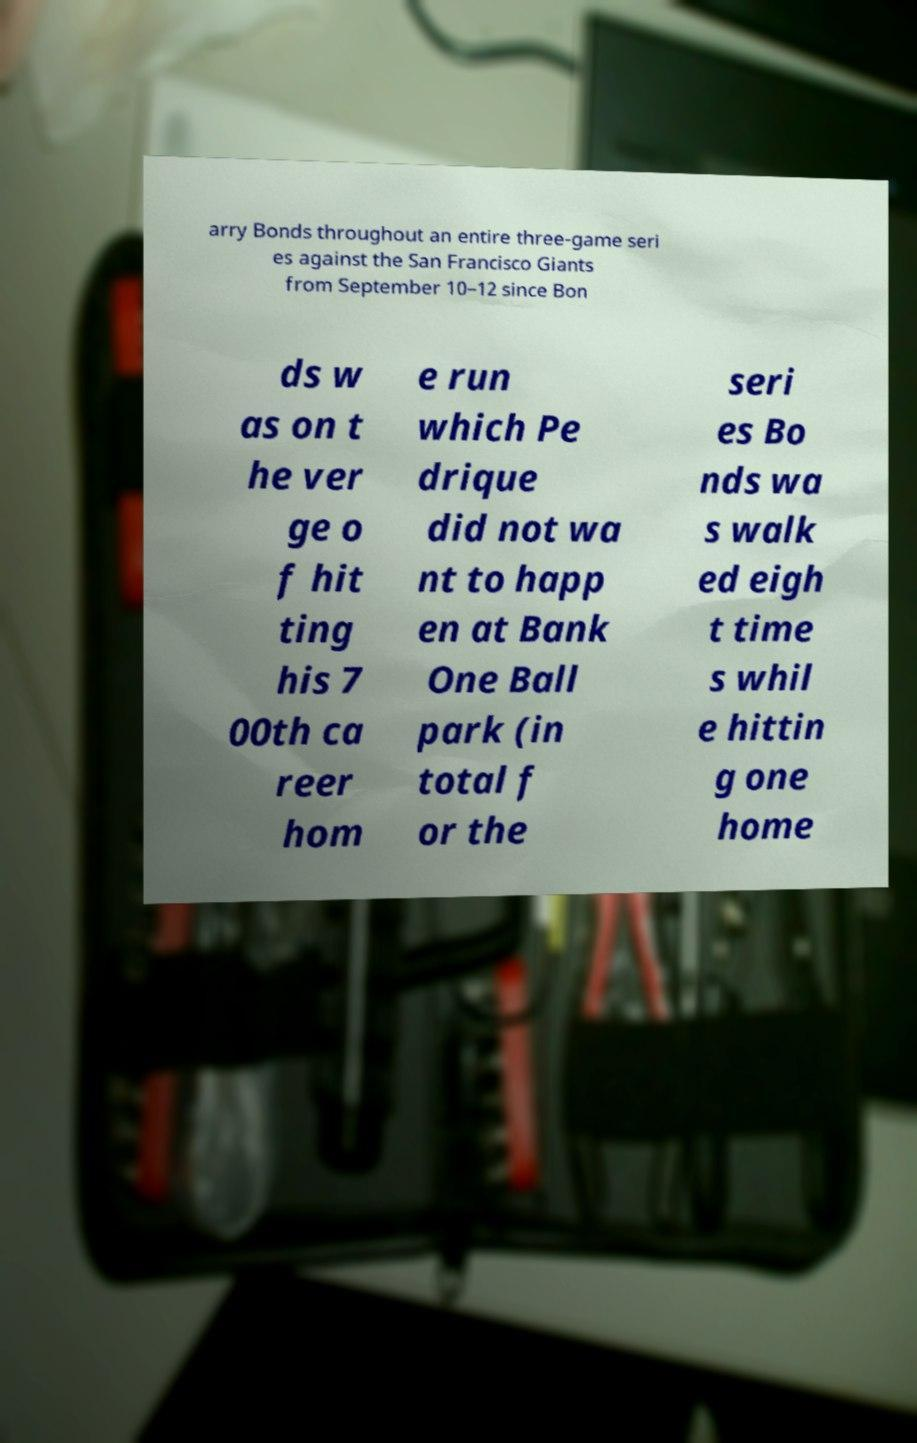For documentation purposes, I need the text within this image transcribed. Could you provide that? arry Bonds throughout an entire three-game seri es against the San Francisco Giants from September 10–12 since Bon ds w as on t he ver ge o f hit ting his 7 00th ca reer hom e run which Pe drique did not wa nt to happ en at Bank One Ball park (in total f or the seri es Bo nds wa s walk ed eigh t time s whil e hittin g one home 